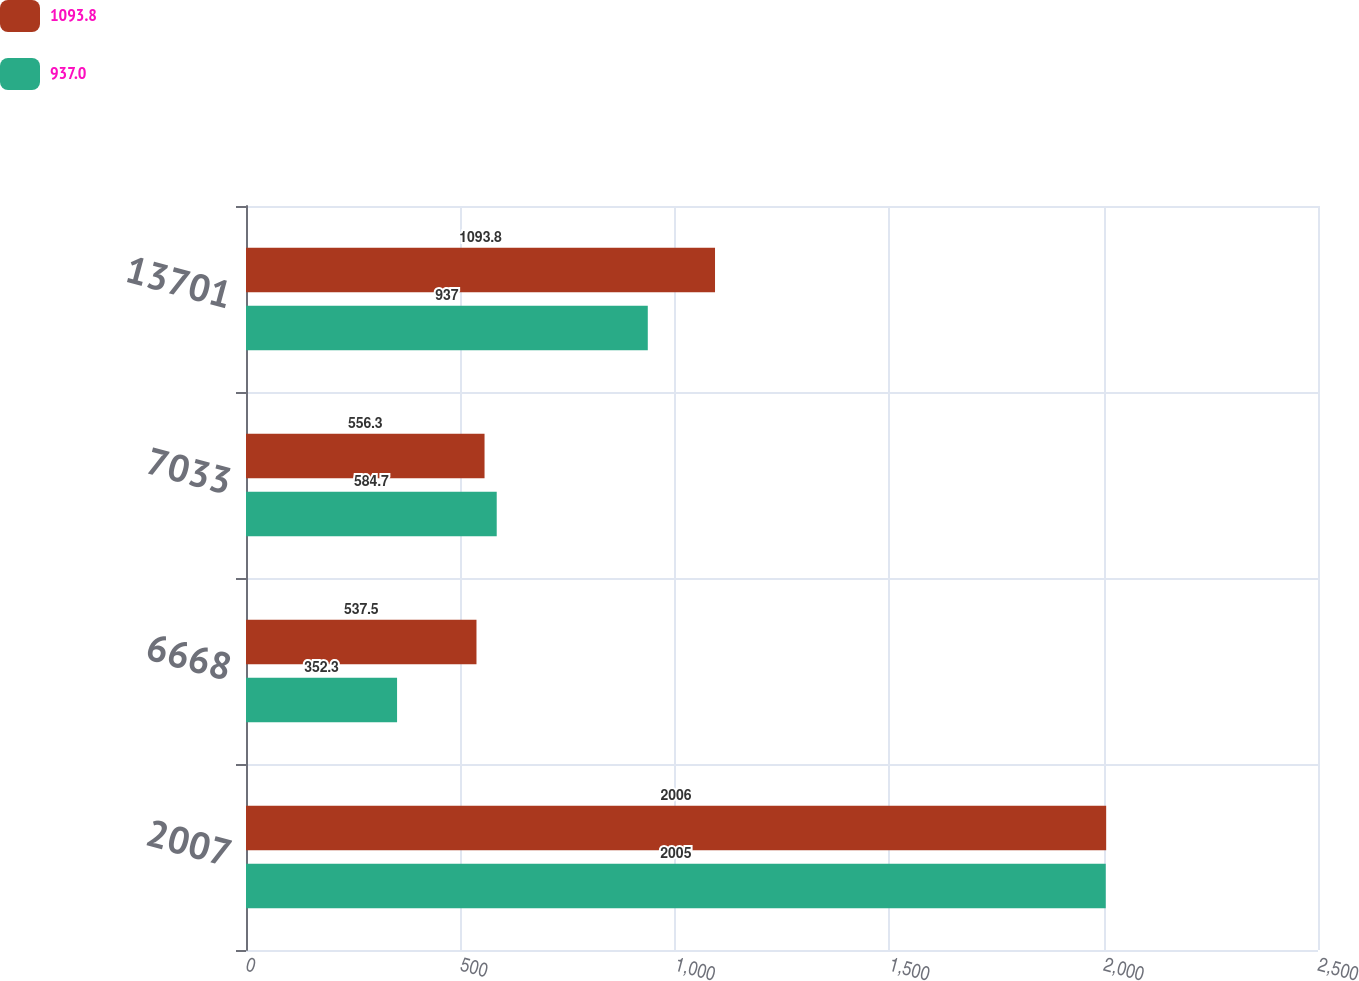Convert chart to OTSL. <chart><loc_0><loc_0><loc_500><loc_500><stacked_bar_chart><ecel><fcel>2007<fcel>6668<fcel>7033<fcel>13701<nl><fcel>1093.8<fcel>2006<fcel>537.5<fcel>556.3<fcel>1093.8<nl><fcel>937<fcel>2005<fcel>352.3<fcel>584.7<fcel>937<nl></chart> 